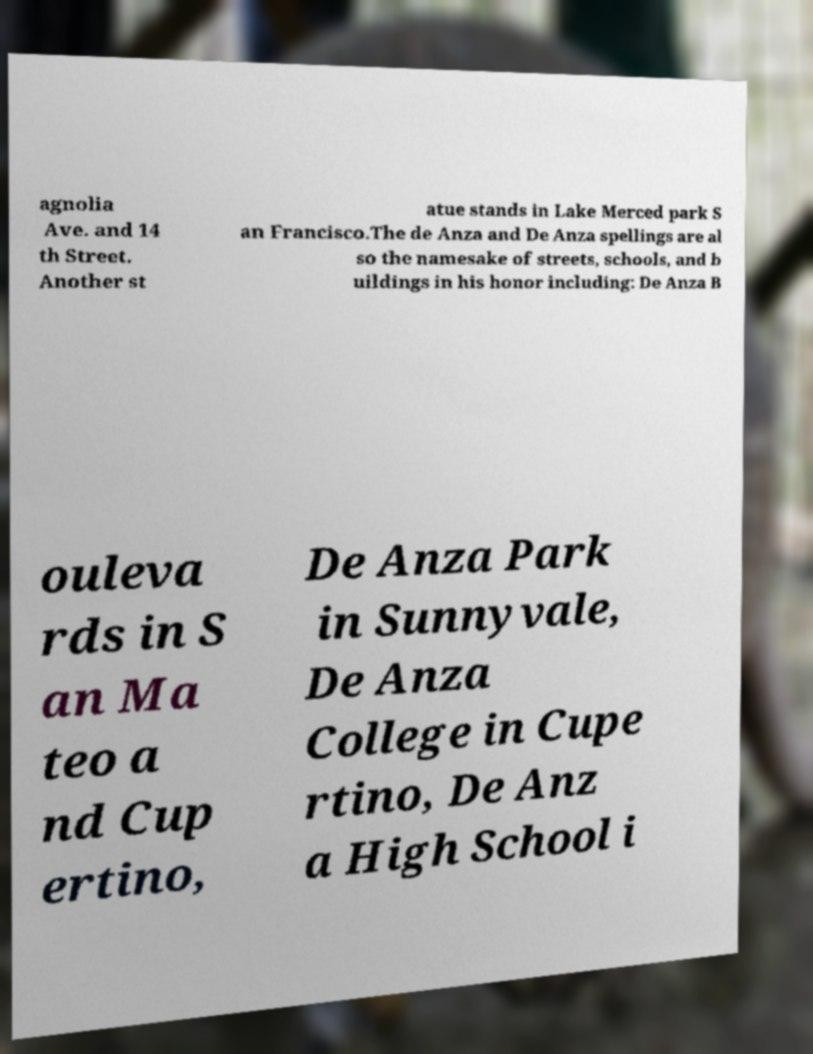I need the written content from this picture converted into text. Can you do that? agnolia Ave. and 14 th Street. Another st atue stands in Lake Merced park S an Francisco.The de Anza and De Anza spellings are al so the namesake of streets, schools, and b uildings in his honor including: De Anza B ouleva rds in S an Ma teo a nd Cup ertino, De Anza Park in Sunnyvale, De Anza College in Cupe rtino, De Anz a High School i 